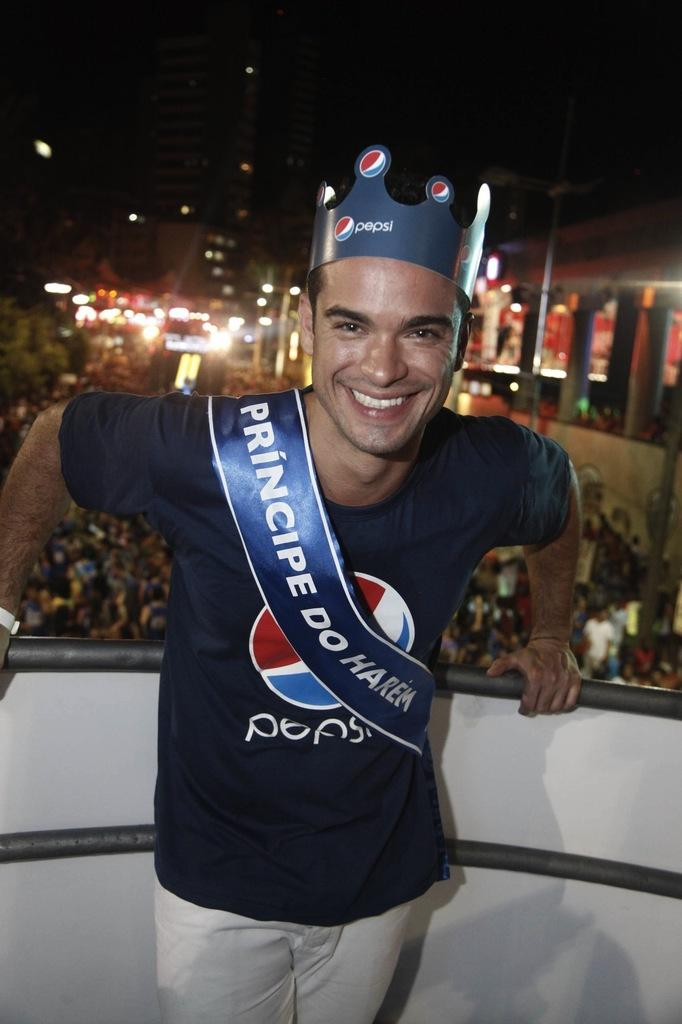<image>
Share a concise interpretation of the image provided. a man that is wearing a Pepsi shirt 